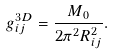Convert formula to latex. <formula><loc_0><loc_0><loc_500><loc_500>g _ { i j } ^ { 3 D } = \frac { M _ { 0 } } { 2 \pi ^ { 2 } R _ { i j } ^ { 2 } } .</formula> 